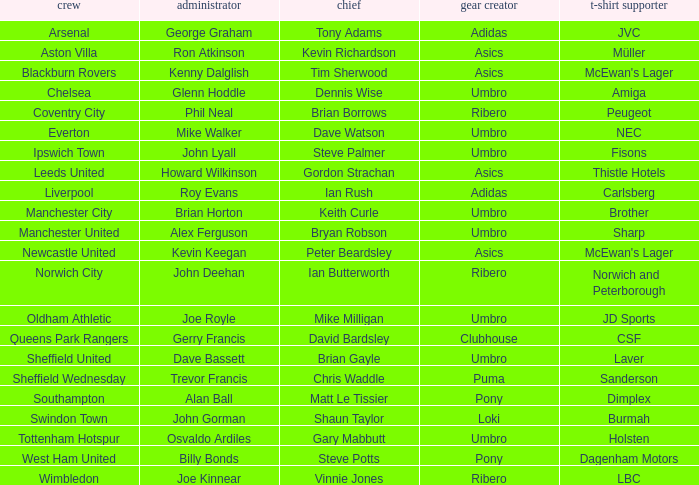Which captain has howard wilkinson as the manager? Gordon Strachan. 